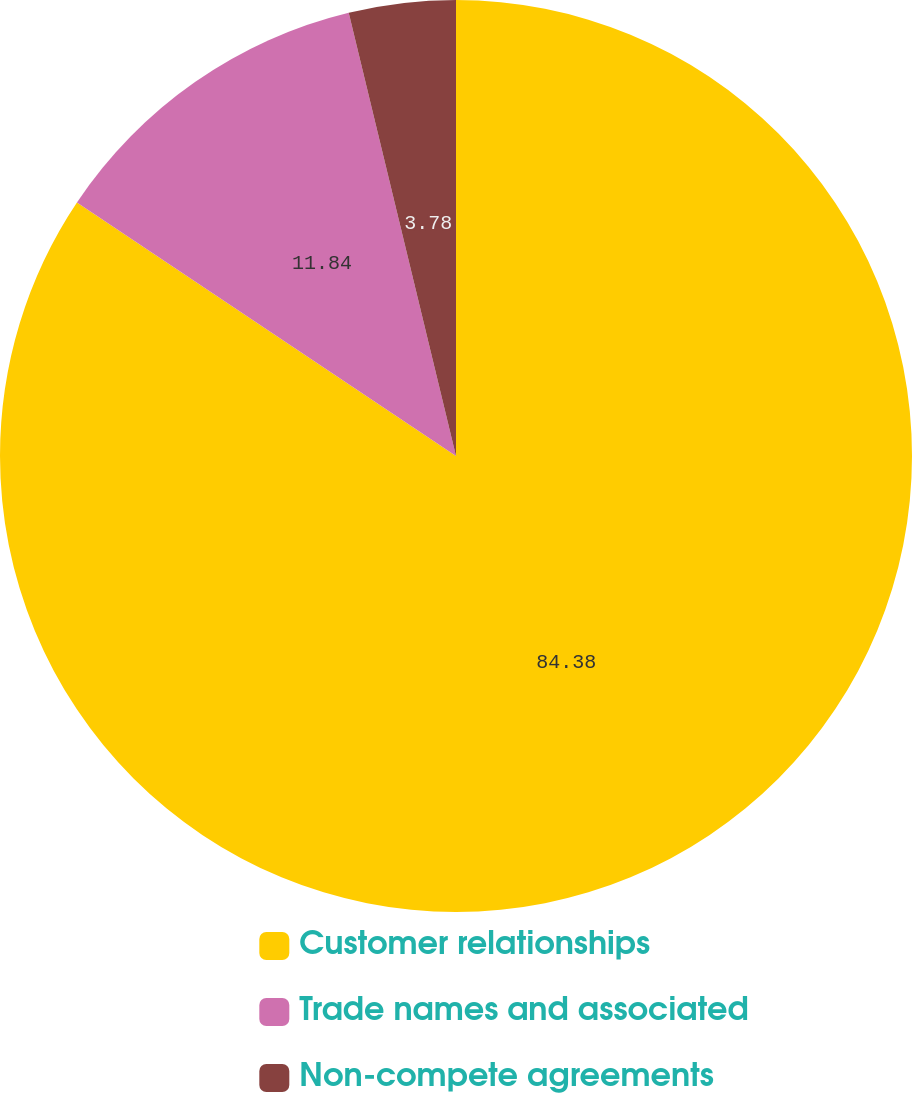Convert chart to OTSL. <chart><loc_0><loc_0><loc_500><loc_500><pie_chart><fcel>Customer relationships<fcel>Trade names and associated<fcel>Non-compete agreements<nl><fcel>84.38%<fcel>11.84%<fcel>3.78%<nl></chart> 